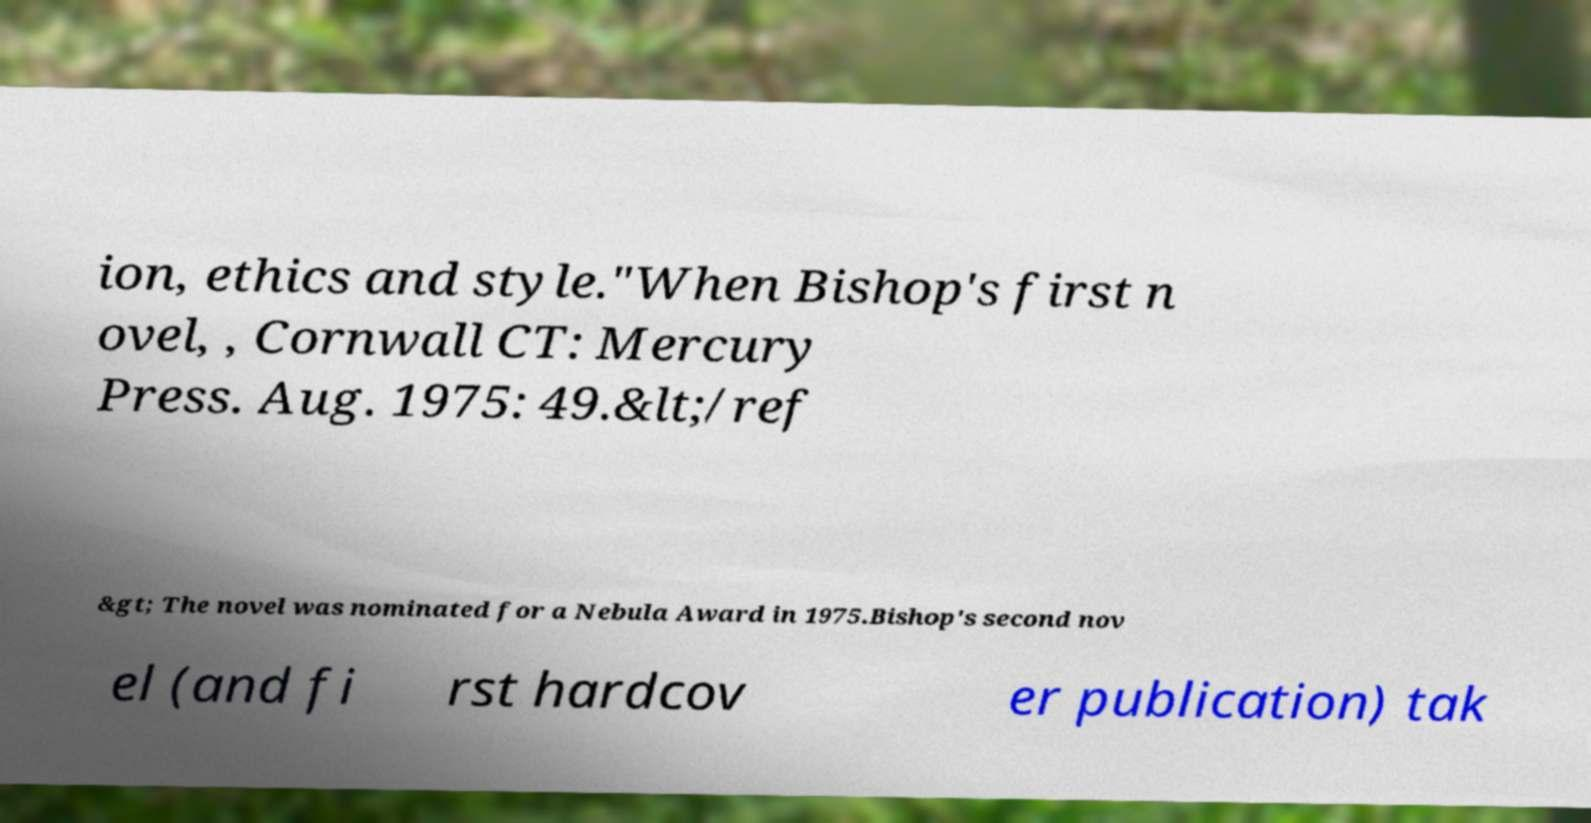Please read and relay the text visible in this image. What does it say? ion, ethics and style."When Bishop's first n ovel, , Cornwall CT: Mercury Press. Aug. 1975: 49.&lt;/ref &gt; The novel was nominated for a Nebula Award in 1975.Bishop's second nov el (and fi rst hardcov er publication) tak 